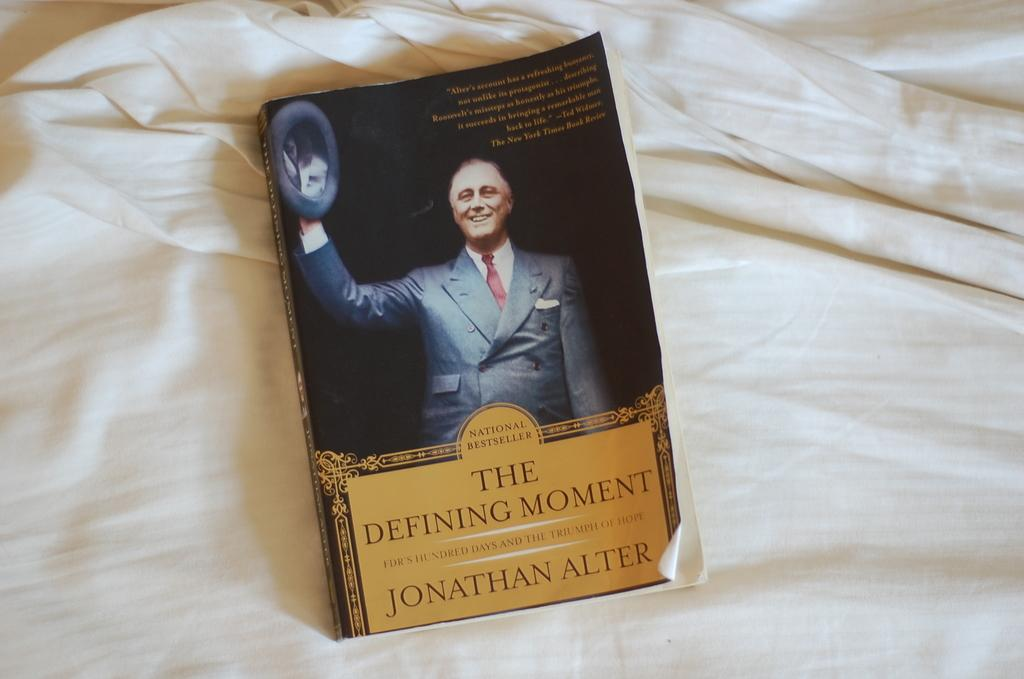What is the main object in the image? There is a book in the image. What is the book placed on? The book is on a cloth. What can be seen on the book's cover? The book has text and images on its cover. Can you tell me how many kittens are sitting on the book in the image? There are no kittens present in the image; it only features a book with text and images on its cover. Is there a doctor examining the book in the image? There is no doctor present in the image; it only features a book with text and images on its cover. 